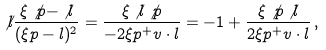Convert formula to latex. <formula><loc_0><loc_0><loc_500><loc_500>\not l \frac { \xi \not p - \not l } { ( \xi p - l ) ^ { 2 } } = \frac { \xi \not l \not p } { - 2 \xi p ^ { + } v \cdot l } = - 1 + \frac { \xi \not p \not l } { 2 \xi p ^ { + } v \cdot l } \, ,</formula> 